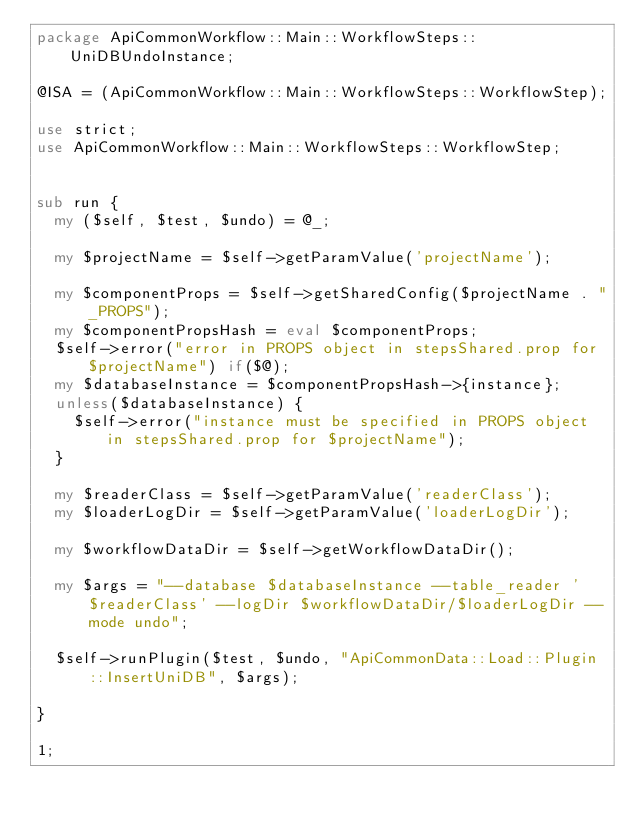<code> <loc_0><loc_0><loc_500><loc_500><_Perl_>package ApiCommonWorkflow::Main::WorkflowSteps::UniDBUndoInstance;

@ISA = (ApiCommonWorkflow::Main::WorkflowSteps::WorkflowStep);

use strict;
use ApiCommonWorkflow::Main::WorkflowSteps::WorkflowStep;


sub run {
  my ($self, $test, $undo) = @_;

  my $projectName = $self->getParamValue('projectName');

  my $componentProps = $self->getSharedConfig($projectName . "_PROPS");
  my $componentPropsHash = eval $componentProps;
  $self->error("error in PROPS object in stepsShared.prop for $projectName") if($@);
  my $databaseInstance = $componentPropsHash->{instance};
  unless($databaseInstance) {
    $self->error("instance must be specified in PROPS object in stepsShared.prop for $projectName");
  }

  my $readerClass = $self->getParamValue('readerClass');
  my $loaderLogDir = $self->getParamValue('loaderLogDir');

  my $workflowDataDir = $self->getWorkflowDataDir();

  my $args = "--database $databaseInstance --table_reader '$readerClass' --logDir $workflowDataDir/$loaderLogDir --mode undo";

  $self->runPlugin($test, $undo, "ApiCommonData::Load::Plugin::InsertUniDB", $args);

}

1;
</code> 